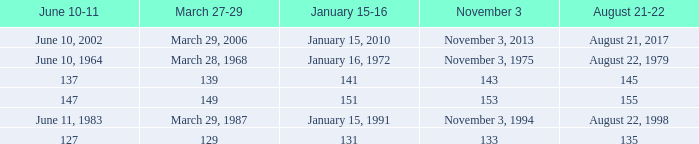Parse the full table. {'header': ['June 10-11', 'March 27-29', 'January 15-16', 'November 3', 'August 21-22'], 'rows': [['June 10, 2002', 'March 29, 2006', 'January 15, 2010', 'November 3, 2013', 'August 21, 2017'], ['June 10, 1964', 'March 28, 1968', 'January 16, 1972', 'November 3, 1975', 'August 22, 1979'], ['137', '139', '141', '143', '145'], ['147', '149', '151', '153', '155'], ['June 11, 1983', 'March 29, 1987', 'January 15, 1991', 'November 3, 1994', 'August 22, 1998'], ['127', '129', '131', '133', '135']]} What number is shown for november 3 where january 15-16 is 151? 153.0. 